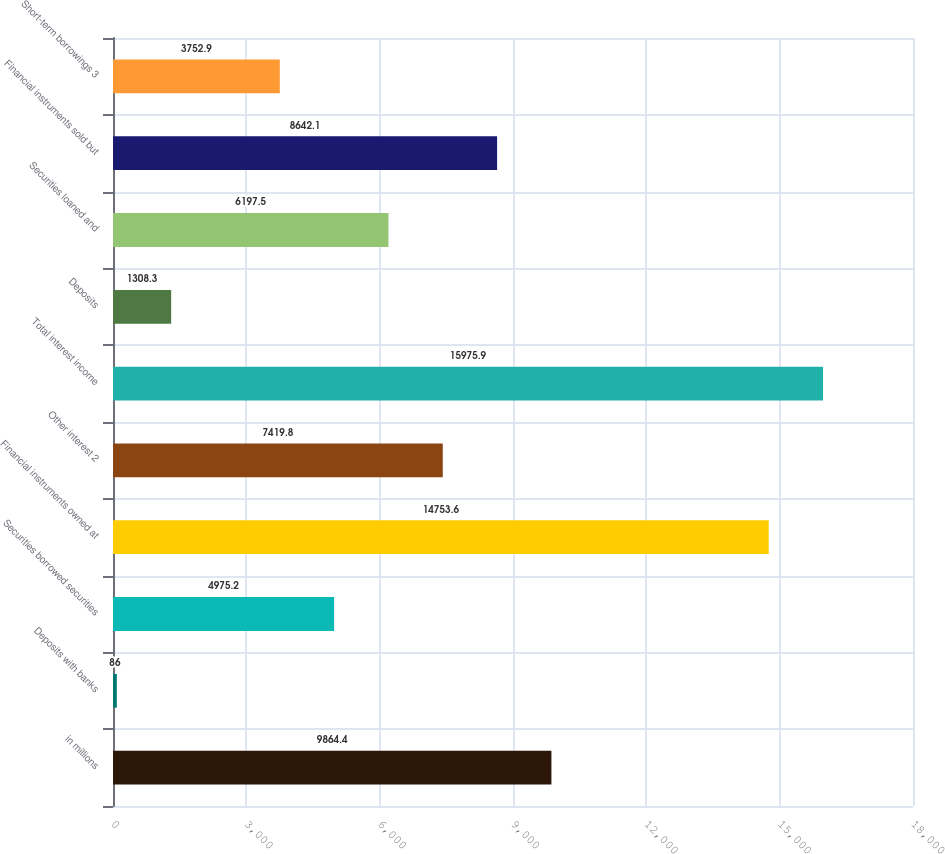Convert chart. <chart><loc_0><loc_0><loc_500><loc_500><bar_chart><fcel>in millions<fcel>Deposits with banks<fcel>Securities borrowed securities<fcel>Financial instruments owned at<fcel>Other interest 2<fcel>Total interest income<fcel>Deposits<fcel>Securities loaned and<fcel>Financial instruments sold but<fcel>Short-term borrowings 3<nl><fcel>9864.4<fcel>86<fcel>4975.2<fcel>14753.6<fcel>7419.8<fcel>15975.9<fcel>1308.3<fcel>6197.5<fcel>8642.1<fcel>3752.9<nl></chart> 